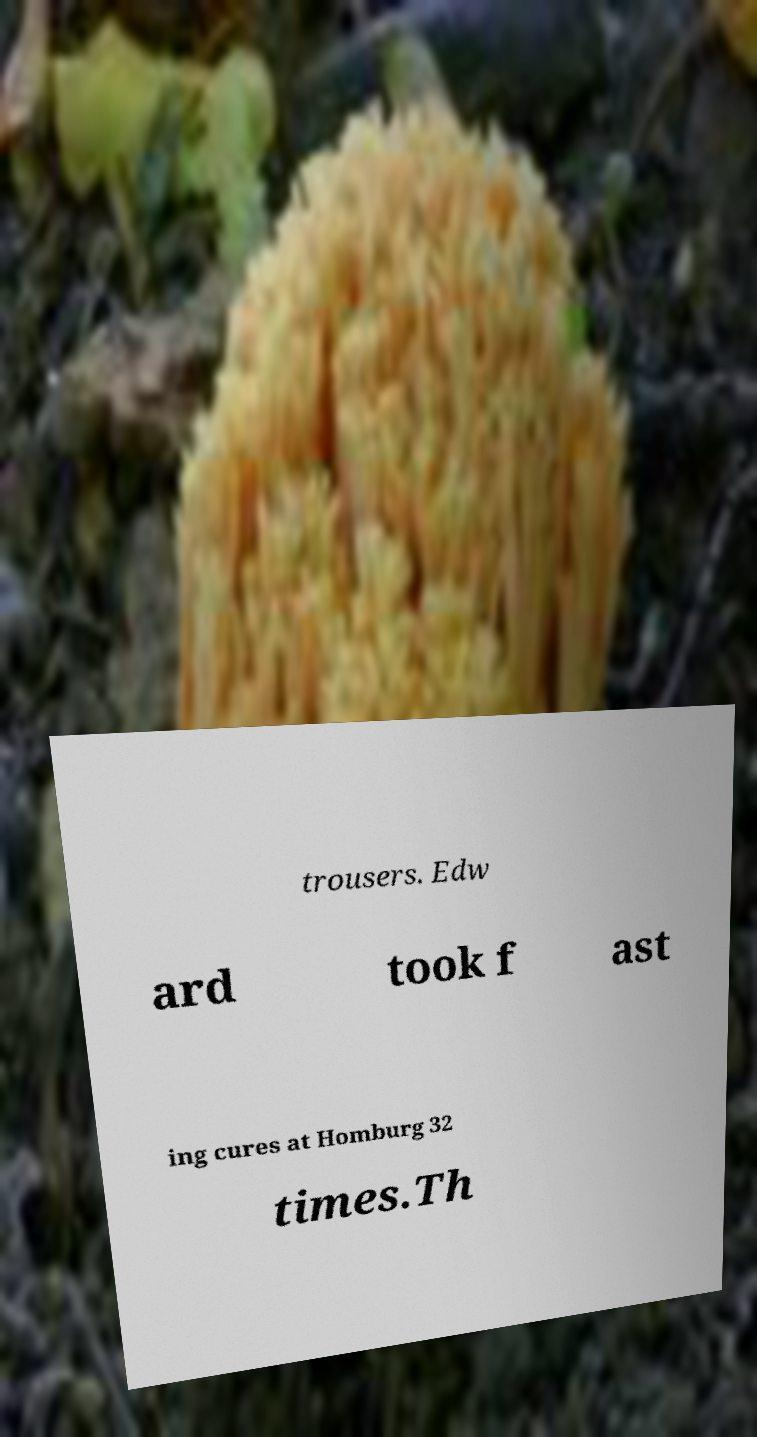Could you extract and type out the text from this image? trousers. Edw ard took f ast ing cures at Homburg 32 times.Th 